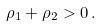<formula> <loc_0><loc_0><loc_500><loc_500>\rho _ { 1 } + \rho _ { 2 } > 0 \, .</formula> 